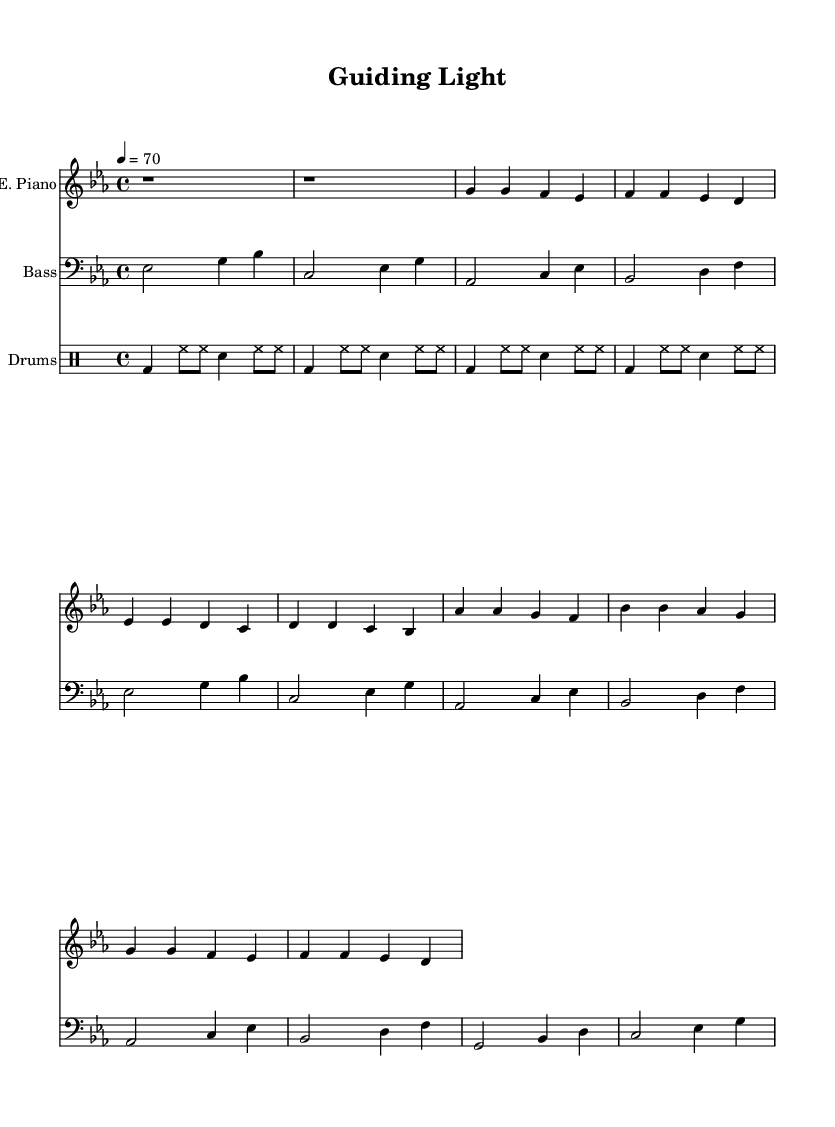What is the key signature of this music? The key signature is E-flat major, indicated by three flats on the staff. This is determined by looking at the key signature section at the beginning of the staff.
Answer: E-flat major What is the time signature of this music? The time signature is four-four, which means there are four beats in each measure. This can be found at the beginning of the score next to the clef and key signature.
Answer: Four-four What is the tempo marking for this music? The tempo marking is seventy beats per minute, indicating the speed of the piece. This information is found at the beginning of the score next to the time signature.
Answer: Seventy How many measures are in the intro section? The intro section contains two measures, as represented by the two sets of rests at the beginning of the score for the electric piano part.
Answer: Two What instrument plays the bass line? The bass line is played by the bass guitar, as indicated by the staff label. The notation is specifically written in the bass clef, indicating that it is intended for the bass guitar.
Answer: Bass guitar How do the chords in the chorus differ from those in the verse? The chorus includes the notes A-flat and B-flat as the starting chords, differentiating it from the verse, which begins with G and F. The contrast between these notes is significant and showcases the thematic change from the verse to the chorus.
Answer: A-flat and B-flat What rhythmic pattern is characteristic of funk in this music? The characteristic rhythmic pattern includes syncopated beats and accents, which are visible in the drum part. This helps create the groove typical of the funk genre, specifically the use of bass drum on the downbeats and snare accents.
Answer: Syncopation 